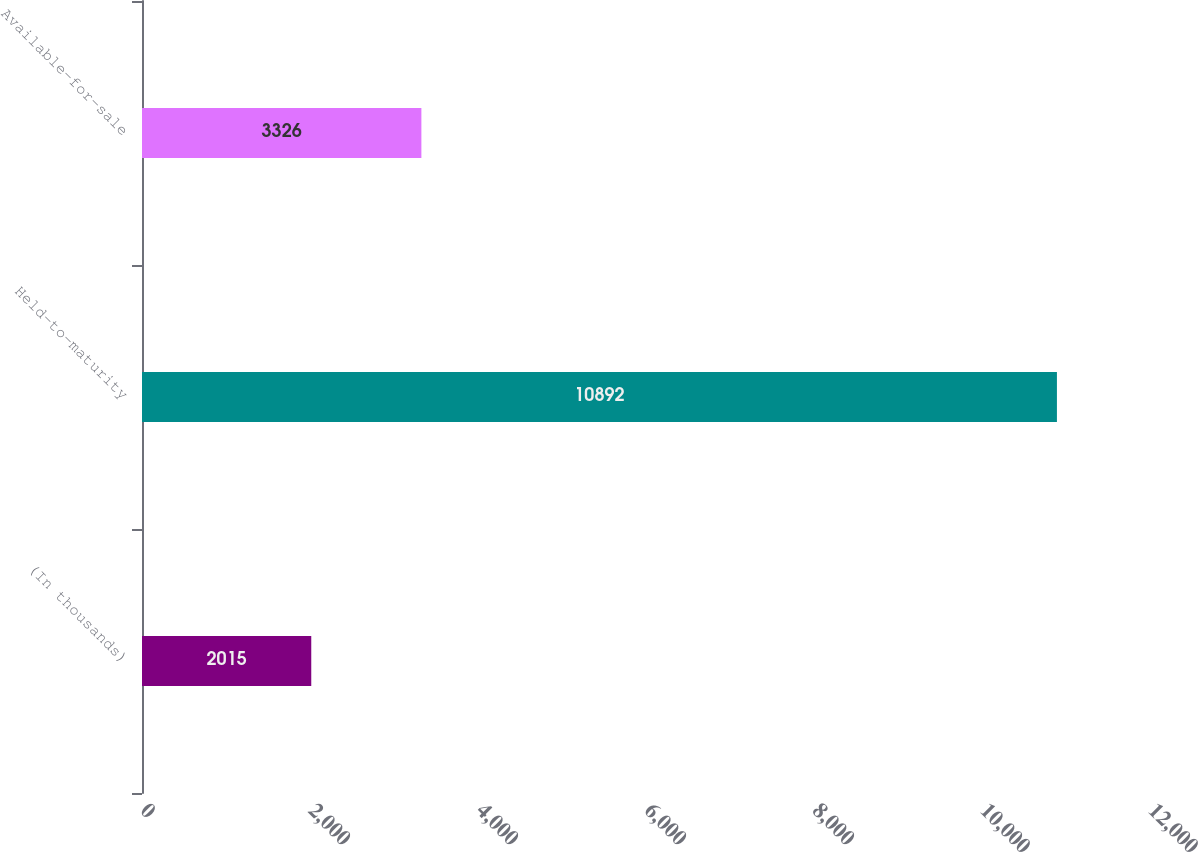Convert chart to OTSL. <chart><loc_0><loc_0><loc_500><loc_500><bar_chart><fcel>(In thousands)<fcel>Held-to-maturity<fcel>Available-for-sale<nl><fcel>2015<fcel>10892<fcel>3326<nl></chart> 